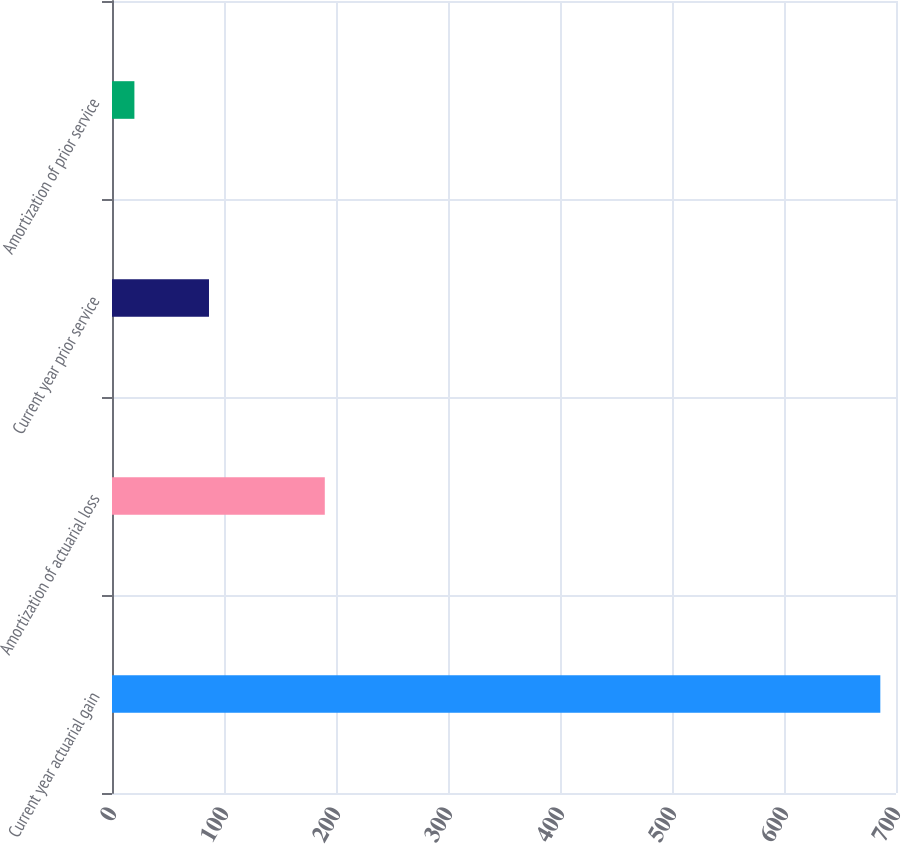Convert chart to OTSL. <chart><loc_0><loc_0><loc_500><loc_500><bar_chart><fcel>Current year actuarial gain<fcel>Amortization of actuarial loss<fcel>Current year prior service<fcel>Amortization of prior service<nl><fcel>686<fcel>190<fcel>86.6<fcel>20<nl></chart> 